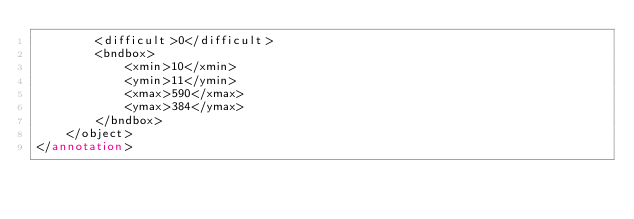<code> <loc_0><loc_0><loc_500><loc_500><_XML_>		<difficult>0</difficult>
		<bndbox>
			<xmin>10</xmin>
			<ymin>11</ymin>
			<xmax>590</xmax>
			<ymax>384</ymax>
		</bndbox>
	</object>
</annotation>
</code> 